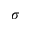<formula> <loc_0><loc_0><loc_500><loc_500>\sigma</formula> 